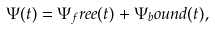<formula> <loc_0><loc_0><loc_500><loc_500>\Psi ( t ) = \Psi _ { f } r e e ( t ) + \Psi _ { b } o u n d ( t ) ,</formula> 